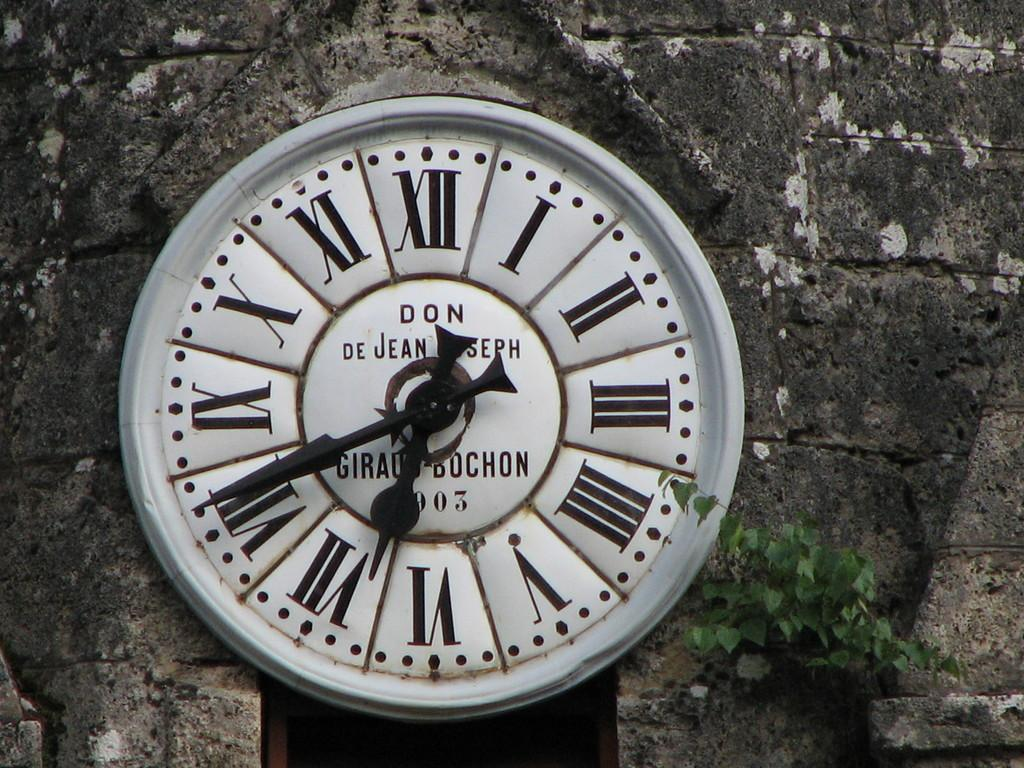<image>
Relay a brief, clear account of the picture shown. A clock with writing "DON DE JEAN JOSEPH" showing 6:41. 